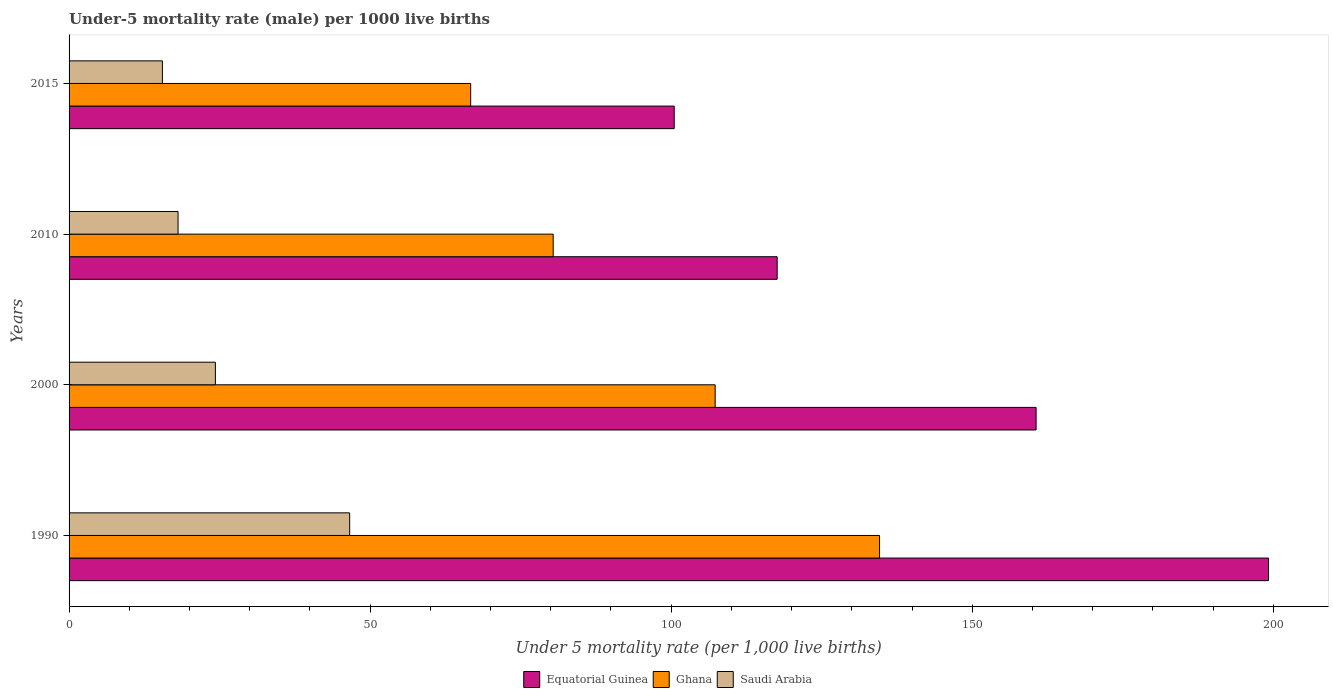How many groups of bars are there?
Your response must be concise. 4. Are the number of bars per tick equal to the number of legend labels?
Your response must be concise. Yes. How many bars are there on the 3rd tick from the bottom?
Make the answer very short. 3. What is the under-five mortality rate in Saudi Arabia in 2015?
Provide a short and direct response. 15.5. Across all years, what is the maximum under-five mortality rate in Saudi Arabia?
Provide a succinct answer. 46.6. Across all years, what is the minimum under-five mortality rate in Equatorial Guinea?
Your answer should be very brief. 100.5. In which year was the under-five mortality rate in Saudi Arabia minimum?
Offer a terse response. 2015. What is the total under-five mortality rate in Ghana in the graph?
Your answer should be compact. 389. What is the difference between the under-five mortality rate in Ghana in 2000 and that in 2010?
Provide a short and direct response. 26.9. What is the difference between the under-five mortality rate in Saudi Arabia in 1990 and the under-five mortality rate in Equatorial Guinea in 2010?
Keep it short and to the point. -71. What is the average under-five mortality rate in Ghana per year?
Your answer should be very brief. 97.25. In the year 2000, what is the difference between the under-five mortality rate in Saudi Arabia and under-five mortality rate in Ghana?
Make the answer very short. -83. In how many years, is the under-five mortality rate in Ghana greater than 80 ?
Your answer should be compact. 3. What is the ratio of the under-five mortality rate in Equatorial Guinea in 2000 to that in 2015?
Your answer should be compact. 1.6. Is the under-five mortality rate in Ghana in 2010 less than that in 2015?
Keep it short and to the point. No. Is the difference between the under-five mortality rate in Saudi Arabia in 2000 and 2010 greater than the difference between the under-five mortality rate in Ghana in 2000 and 2010?
Keep it short and to the point. No. What is the difference between the highest and the second highest under-five mortality rate in Ghana?
Provide a short and direct response. 27.3. What is the difference between the highest and the lowest under-five mortality rate in Ghana?
Offer a terse response. 67.9. What does the 1st bar from the top in 1990 represents?
Ensure brevity in your answer.  Saudi Arabia. What does the 3rd bar from the bottom in 2000 represents?
Give a very brief answer. Saudi Arabia. How many bars are there?
Your answer should be very brief. 12. Are all the bars in the graph horizontal?
Provide a succinct answer. Yes. What is the difference between two consecutive major ticks on the X-axis?
Your response must be concise. 50. Are the values on the major ticks of X-axis written in scientific E-notation?
Offer a terse response. No. How many legend labels are there?
Offer a very short reply. 3. How are the legend labels stacked?
Make the answer very short. Horizontal. What is the title of the graph?
Provide a succinct answer. Under-5 mortality rate (male) per 1000 live births. What is the label or title of the X-axis?
Your answer should be very brief. Under 5 mortality rate (per 1,0 live births). What is the label or title of the Y-axis?
Your response must be concise. Years. What is the Under 5 mortality rate (per 1,000 live births) in Equatorial Guinea in 1990?
Offer a very short reply. 199.2. What is the Under 5 mortality rate (per 1,000 live births) of Ghana in 1990?
Offer a very short reply. 134.6. What is the Under 5 mortality rate (per 1,000 live births) in Saudi Arabia in 1990?
Make the answer very short. 46.6. What is the Under 5 mortality rate (per 1,000 live births) in Equatorial Guinea in 2000?
Give a very brief answer. 160.6. What is the Under 5 mortality rate (per 1,000 live births) in Ghana in 2000?
Ensure brevity in your answer.  107.3. What is the Under 5 mortality rate (per 1,000 live births) in Saudi Arabia in 2000?
Your response must be concise. 24.3. What is the Under 5 mortality rate (per 1,000 live births) of Equatorial Guinea in 2010?
Keep it short and to the point. 117.6. What is the Under 5 mortality rate (per 1,000 live births) in Ghana in 2010?
Your response must be concise. 80.4. What is the Under 5 mortality rate (per 1,000 live births) in Equatorial Guinea in 2015?
Make the answer very short. 100.5. What is the Under 5 mortality rate (per 1,000 live births) of Ghana in 2015?
Provide a succinct answer. 66.7. Across all years, what is the maximum Under 5 mortality rate (per 1,000 live births) of Equatorial Guinea?
Offer a terse response. 199.2. Across all years, what is the maximum Under 5 mortality rate (per 1,000 live births) of Ghana?
Make the answer very short. 134.6. Across all years, what is the maximum Under 5 mortality rate (per 1,000 live births) in Saudi Arabia?
Ensure brevity in your answer.  46.6. Across all years, what is the minimum Under 5 mortality rate (per 1,000 live births) in Equatorial Guinea?
Keep it short and to the point. 100.5. Across all years, what is the minimum Under 5 mortality rate (per 1,000 live births) of Ghana?
Offer a very short reply. 66.7. What is the total Under 5 mortality rate (per 1,000 live births) in Equatorial Guinea in the graph?
Your response must be concise. 577.9. What is the total Under 5 mortality rate (per 1,000 live births) of Ghana in the graph?
Give a very brief answer. 389. What is the total Under 5 mortality rate (per 1,000 live births) in Saudi Arabia in the graph?
Give a very brief answer. 104.5. What is the difference between the Under 5 mortality rate (per 1,000 live births) of Equatorial Guinea in 1990 and that in 2000?
Your answer should be compact. 38.6. What is the difference between the Under 5 mortality rate (per 1,000 live births) in Ghana in 1990 and that in 2000?
Your answer should be very brief. 27.3. What is the difference between the Under 5 mortality rate (per 1,000 live births) in Saudi Arabia in 1990 and that in 2000?
Keep it short and to the point. 22.3. What is the difference between the Under 5 mortality rate (per 1,000 live births) in Equatorial Guinea in 1990 and that in 2010?
Offer a very short reply. 81.6. What is the difference between the Under 5 mortality rate (per 1,000 live births) of Ghana in 1990 and that in 2010?
Make the answer very short. 54.2. What is the difference between the Under 5 mortality rate (per 1,000 live births) of Saudi Arabia in 1990 and that in 2010?
Make the answer very short. 28.5. What is the difference between the Under 5 mortality rate (per 1,000 live births) in Equatorial Guinea in 1990 and that in 2015?
Keep it short and to the point. 98.7. What is the difference between the Under 5 mortality rate (per 1,000 live births) in Ghana in 1990 and that in 2015?
Offer a terse response. 67.9. What is the difference between the Under 5 mortality rate (per 1,000 live births) of Saudi Arabia in 1990 and that in 2015?
Provide a short and direct response. 31.1. What is the difference between the Under 5 mortality rate (per 1,000 live births) in Equatorial Guinea in 2000 and that in 2010?
Make the answer very short. 43. What is the difference between the Under 5 mortality rate (per 1,000 live births) in Ghana in 2000 and that in 2010?
Make the answer very short. 26.9. What is the difference between the Under 5 mortality rate (per 1,000 live births) in Saudi Arabia in 2000 and that in 2010?
Provide a succinct answer. 6.2. What is the difference between the Under 5 mortality rate (per 1,000 live births) in Equatorial Guinea in 2000 and that in 2015?
Give a very brief answer. 60.1. What is the difference between the Under 5 mortality rate (per 1,000 live births) in Ghana in 2000 and that in 2015?
Your response must be concise. 40.6. What is the difference between the Under 5 mortality rate (per 1,000 live births) of Saudi Arabia in 2000 and that in 2015?
Ensure brevity in your answer.  8.8. What is the difference between the Under 5 mortality rate (per 1,000 live births) in Ghana in 2010 and that in 2015?
Give a very brief answer. 13.7. What is the difference between the Under 5 mortality rate (per 1,000 live births) in Equatorial Guinea in 1990 and the Under 5 mortality rate (per 1,000 live births) in Ghana in 2000?
Your response must be concise. 91.9. What is the difference between the Under 5 mortality rate (per 1,000 live births) in Equatorial Guinea in 1990 and the Under 5 mortality rate (per 1,000 live births) in Saudi Arabia in 2000?
Make the answer very short. 174.9. What is the difference between the Under 5 mortality rate (per 1,000 live births) in Ghana in 1990 and the Under 5 mortality rate (per 1,000 live births) in Saudi Arabia in 2000?
Give a very brief answer. 110.3. What is the difference between the Under 5 mortality rate (per 1,000 live births) of Equatorial Guinea in 1990 and the Under 5 mortality rate (per 1,000 live births) of Ghana in 2010?
Provide a short and direct response. 118.8. What is the difference between the Under 5 mortality rate (per 1,000 live births) of Equatorial Guinea in 1990 and the Under 5 mortality rate (per 1,000 live births) of Saudi Arabia in 2010?
Your response must be concise. 181.1. What is the difference between the Under 5 mortality rate (per 1,000 live births) in Ghana in 1990 and the Under 5 mortality rate (per 1,000 live births) in Saudi Arabia in 2010?
Keep it short and to the point. 116.5. What is the difference between the Under 5 mortality rate (per 1,000 live births) in Equatorial Guinea in 1990 and the Under 5 mortality rate (per 1,000 live births) in Ghana in 2015?
Keep it short and to the point. 132.5. What is the difference between the Under 5 mortality rate (per 1,000 live births) in Equatorial Guinea in 1990 and the Under 5 mortality rate (per 1,000 live births) in Saudi Arabia in 2015?
Provide a short and direct response. 183.7. What is the difference between the Under 5 mortality rate (per 1,000 live births) of Ghana in 1990 and the Under 5 mortality rate (per 1,000 live births) of Saudi Arabia in 2015?
Keep it short and to the point. 119.1. What is the difference between the Under 5 mortality rate (per 1,000 live births) in Equatorial Guinea in 2000 and the Under 5 mortality rate (per 1,000 live births) in Ghana in 2010?
Provide a succinct answer. 80.2. What is the difference between the Under 5 mortality rate (per 1,000 live births) in Equatorial Guinea in 2000 and the Under 5 mortality rate (per 1,000 live births) in Saudi Arabia in 2010?
Provide a succinct answer. 142.5. What is the difference between the Under 5 mortality rate (per 1,000 live births) in Ghana in 2000 and the Under 5 mortality rate (per 1,000 live births) in Saudi Arabia in 2010?
Give a very brief answer. 89.2. What is the difference between the Under 5 mortality rate (per 1,000 live births) in Equatorial Guinea in 2000 and the Under 5 mortality rate (per 1,000 live births) in Ghana in 2015?
Offer a very short reply. 93.9. What is the difference between the Under 5 mortality rate (per 1,000 live births) in Equatorial Guinea in 2000 and the Under 5 mortality rate (per 1,000 live births) in Saudi Arabia in 2015?
Make the answer very short. 145.1. What is the difference between the Under 5 mortality rate (per 1,000 live births) of Ghana in 2000 and the Under 5 mortality rate (per 1,000 live births) of Saudi Arabia in 2015?
Ensure brevity in your answer.  91.8. What is the difference between the Under 5 mortality rate (per 1,000 live births) of Equatorial Guinea in 2010 and the Under 5 mortality rate (per 1,000 live births) of Ghana in 2015?
Your response must be concise. 50.9. What is the difference between the Under 5 mortality rate (per 1,000 live births) in Equatorial Guinea in 2010 and the Under 5 mortality rate (per 1,000 live births) in Saudi Arabia in 2015?
Offer a very short reply. 102.1. What is the difference between the Under 5 mortality rate (per 1,000 live births) of Ghana in 2010 and the Under 5 mortality rate (per 1,000 live births) of Saudi Arabia in 2015?
Your response must be concise. 64.9. What is the average Under 5 mortality rate (per 1,000 live births) in Equatorial Guinea per year?
Offer a very short reply. 144.47. What is the average Under 5 mortality rate (per 1,000 live births) in Ghana per year?
Offer a terse response. 97.25. What is the average Under 5 mortality rate (per 1,000 live births) of Saudi Arabia per year?
Give a very brief answer. 26.12. In the year 1990, what is the difference between the Under 5 mortality rate (per 1,000 live births) of Equatorial Guinea and Under 5 mortality rate (per 1,000 live births) of Ghana?
Make the answer very short. 64.6. In the year 1990, what is the difference between the Under 5 mortality rate (per 1,000 live births) of Equatorial Guinea and Under 5 mortality rate (per 1,000 live births) of Saudi Arabia?
Offer a terse response. 152.6. In the year 1990, what is the difference between the Under 5 mortality rate (per 1,000 live births) in Ghana and Under 5 mortality rate (per 1,000 live births) in Saudi Arabia?
Provide a short and direct response. 88. In the year 2000, what is the difference between the Under 5 mortality rate (per 1,000 live births) in Equatorial Guinea and Under 5 mortality rate (per 1,000 live births) in Ghana?
Make the answer very short. 53.3. In the year 2000, what is the difference between the Under 5 mortality rate (per 1,000 live births) of Equatorial Guinea and Under 5 mortality rate (per 1,000 live births) of Saudi Arabia?
Provide a succinct answer. 136.3. In the year 2010, what is the difference between the Under 5 mortality rate (per 1,000 live births) of Equatorial Guinea and Under 5 mortality rate (per 1,000 live births) of Ghana?
Give a very brief answer. 37.2. In the year 2010, what is the difference between the Under 5 mortality rate (per 1,000 live births) of Equatorial Guinea and Under 5 mortality rate (per 1,000 live births) of Saudi Arabia?
Provide a short and direct response. 99.5. In the year 2010, what is the difference between the Under 5 mortality rate (per 1,000 live births) in Ghana and Under 5 mortality rate (per 1,000 live births) in Saudi Arabia?
Give a very brief answer. 62.3. In the year 2015, what is the difference between the Under 5 mortality rate (per 1,000 live births) in Equatorial Guinea and Under 5 mortality rate (per 1,000 live births) in Ghana?
Provide a succinct answer. 33.8. In the year 2015, what is the difference between the Under 5 mortality rate (per 1,000 live births) of Equatorial Guinea and Under 5 mortality rate (per 1,000 live births) of Saudi Arabia?
Keep it short and to the point. 85. In the year 2015, what is the difference between the Under 5 mortality rate (per 1,000 live births) in Ghana and Under 5 mortality rate (per 1,000 live births) in Saudi Arabia?
Provide a short and direct response. 51.2. What is the ratio of the Under 5 mortality rate (per 1,000 live births) in Equatorial Guinea in 1990 to that in 2000?
Give a very brief answer. 1.24. What is the ratio of the Under 5 mortality rate (per 1,000 live births) in Ghana in 1990 to that in 2000?
Your answer should be very brief. 1.25. What is the ratio of the Under 5 mortality rate (per 1,000 live births) of Saudi Arabia in 1990 to that in 2000?
Offer a very short reply. 1.92. What is the ratio of the Under 5 mortality rate (per 1,000 live births) in Equatorial Guinea in 1990 to that in 2010?
Provide a succinct answer. 1.69. What is the ratio of the Under 5 mortality rate (per 1,000 live births) of Ghana in 1990 to that in 2010?
Provide a short and direct response. 1.67. What is the ratio of the Under 5 mortality rate (per 1,000 live births) in Saudi Arabia in 1990 to that in 2010?
Offer a terse response. 2.57. What is the ratio of the Under 5 mortality rate (per 1,000 live births) in Equatorial Guinea in 1990 to that in 2015?
Make the answer very short. 1.98. What is the ratio of the Under 5 mortality rate (per 1,000 live births) of Ghana in 1990 to that in 2015?
Offer a very short reply. 2.02. What is the ratio of the Under 5 mortality rate (per 1,000 live births) in Saudi Arabia in 1990 to that in 2015?
Offer a very short reply. 3.01. What is the ratio of the Under 5 mortality rate (per 1,000 live births) of Equatorial Guinea in 2000 to that in 2010?
Ensure brevity in your answer.  1.37. What is the ratio of the Under 5 mortality rate (per 1,000 live births) of Ghana in 2000 to that in 2010?
Your answer should be very brief. 1.33. What is the ratio of the Under 5 mortality rate (per 1,000 live births) in Saudi Arabia in 2000 to that in 2010?
Provide a succinct answer. 1.34. What is the ratio of the Under 5 mortality rate (per 1,000 live births) in Equatorial Guinea in 2000 to that in 2015?
Provide a short and direct response. 1.6. What is the ratio of the Under 5 mortality rate (per 1,000 live births) in Ghana in 2000 to that in 2015?
Offer a terse response. 1.61. What is the ratio of the Under 5 mortality rate (per 1,000 live births) in Saudi Arabia in 2000 to that in 2015?
Your response must be concise. 1.57. What is the ratio of the Under 5 mortality rate (per 1,000 live births) of Equatorial Guinea in 2010 to that in 2015?
Your answer should be very brief. 1.17. What is the ratio of the Under 5 mortality rate (per 1,000 live births) in Ghana in 2010 to that in 2015?
Ensure brevity in your answer.  1.21. What is the ratio of the Under 5 mortality rate (per 1,000 live births) in Saudi Arabia in 2010 to that in 2015?
Give a very brief answer. 1.17. What is the difference between the highest and the second highest Under 5 mortality rate (per 1,000 live births) in Equatorial Guinea?
Make the answer very short. 38.6. What is the difference between the highest and the second highest Under 5 mortality rate (per 1,000 live births) in Ghana?
Offer a very short reply. 27.3. What is the difference between the highest and the second highest Under 5 mortality rate (per 1,000 live births) of Saudi Arabia?
Provide a short and direct response. 22.3. What is the difference between the highest and the lowest Under 5 mortality rate (per 1,000 live births) of Equatorial Guinea?
Provide a short and direct response. 98.7. What is the difference between the highest and the lowest Under 5 mortality rate (per 1,000 live births) in Ghana?
Provide a short and direct response. 67.9. What is the difference between the highest and the lowest Under 5 mortality rate (per 1,000 live births) in Saudi Arabia?
Offer a very short reply. 31.1. 